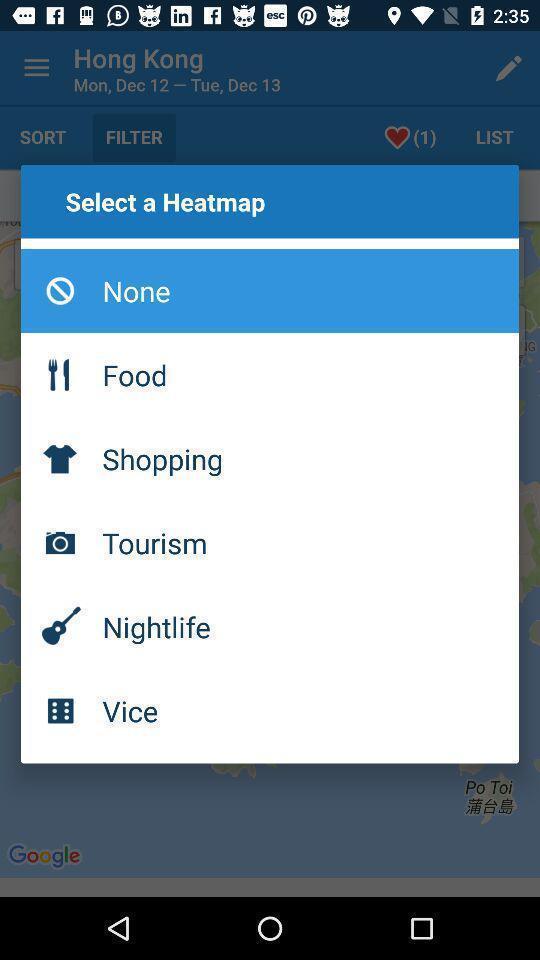Tell me what you see in this picture. Popup page for selecting a heat map for an app. 